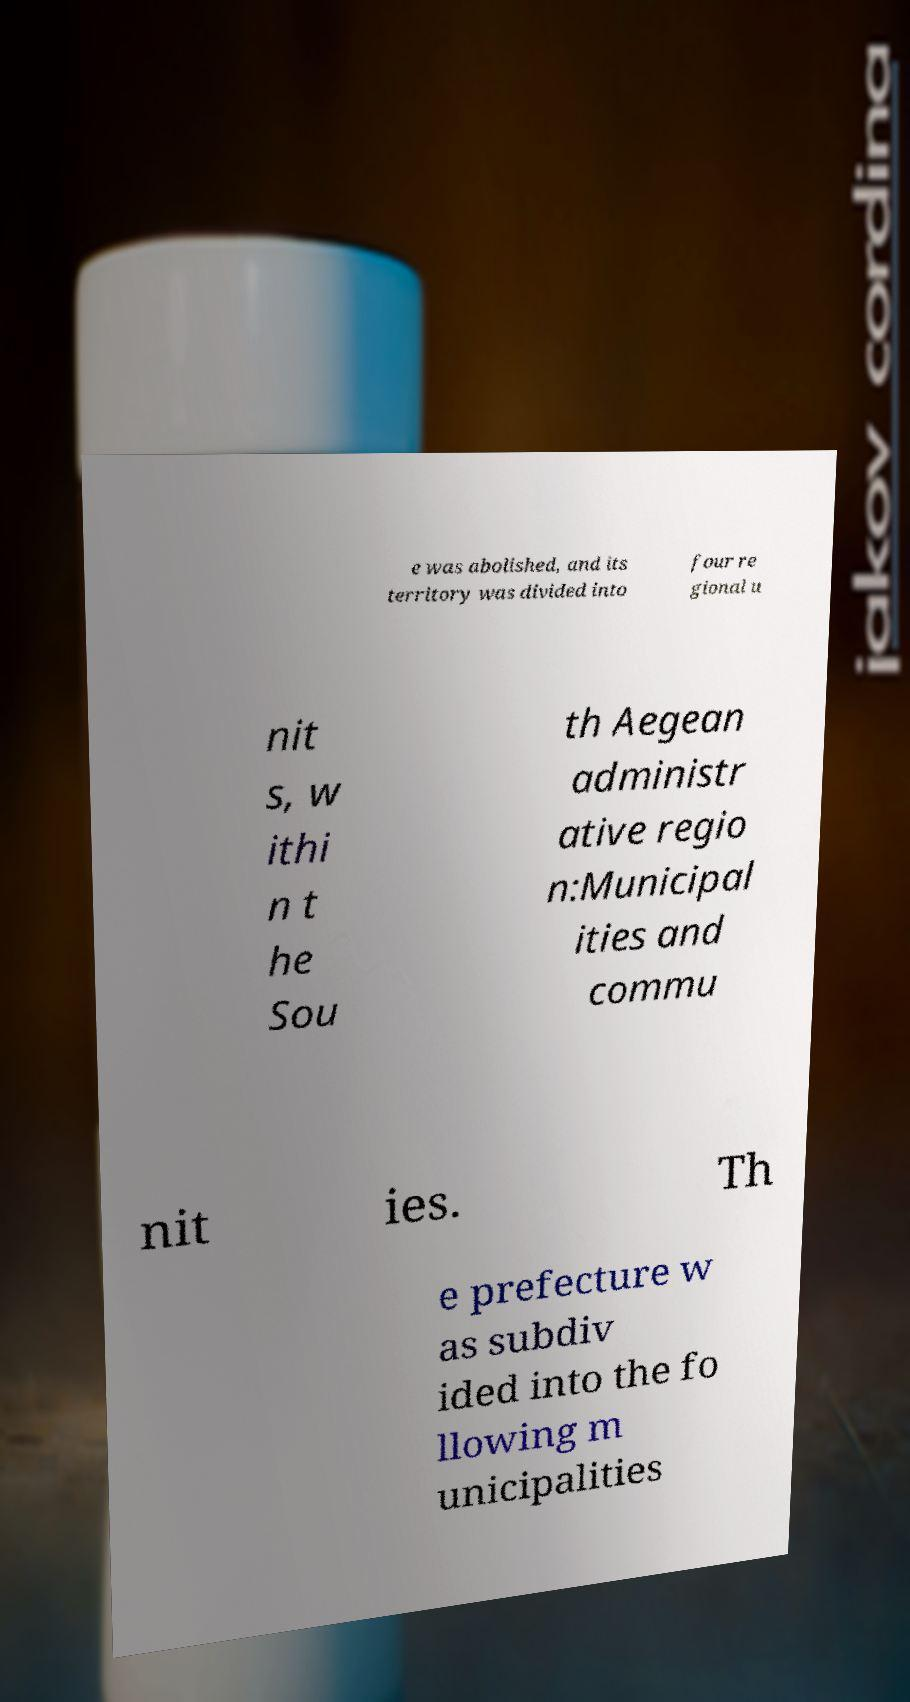Please identify and transcribe the text found in this image. e was abolished, and its territory was divided into four re gional u nit s, w ithi n t he Sou th Aegean administr ative regio n:Municipal ities and commu nit ies. Th e prefecture w as subdiv ided into the fo llowing m unicipalities 